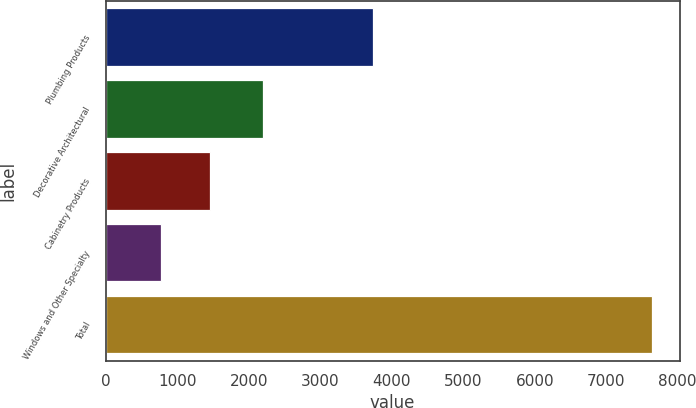Convert chart. <chart><loc_0><loc_0><loc_500><loc_500><bar_chart><fcel>Plumbing Products<fcel>Decorative Architectural<fcel>Cabinetry Products<fcel>Windows and Other Specialty<fcel>Total<nl><fcel>3735<fcel>2205<fcel>1457.4<fcel>770<fcel>7644<nl></chart> 